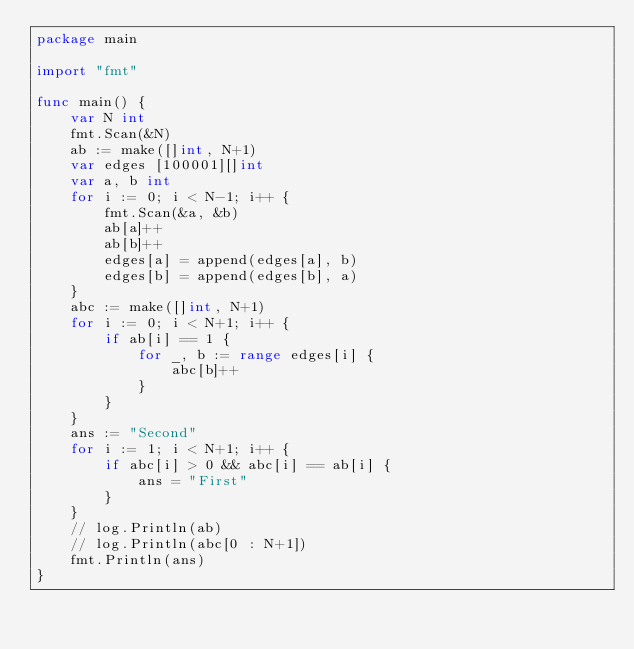<code> <loc_0><loc_0><loc_500><loc_500><_Go_>package main

import "fmt"

func main() {
	var N int
	fmt.Scan(&N)
	ab := make([]int, N+1)
	var edges [100001][]int
	var a, b int
	for i := 0; i < N-1; i++ {
		fmt.Scan(&a, &b)
		ab[a]++
		ab[b]++
		edges[a] = append(edges[a], b)
		edges[b] = append(edges[b], a)
	}
	abc := make([]int, N+1)
	for i := 0; i < N+1; i++ {
		if ab[i] == 1 {
			for _, b := range edges[i] {
				abc[b]++
			}
		}
	}
	ans := "Second"
	for i := 1; i < N+1; i++ {
		if abc[i] > 0 && abc[i] == ab[i] {
			ans = "First"
		}
	}
	// log.Println(ab)
	// log.Println(abc[0 : N+1])
	fmt.Println(ans)
}
</code> 